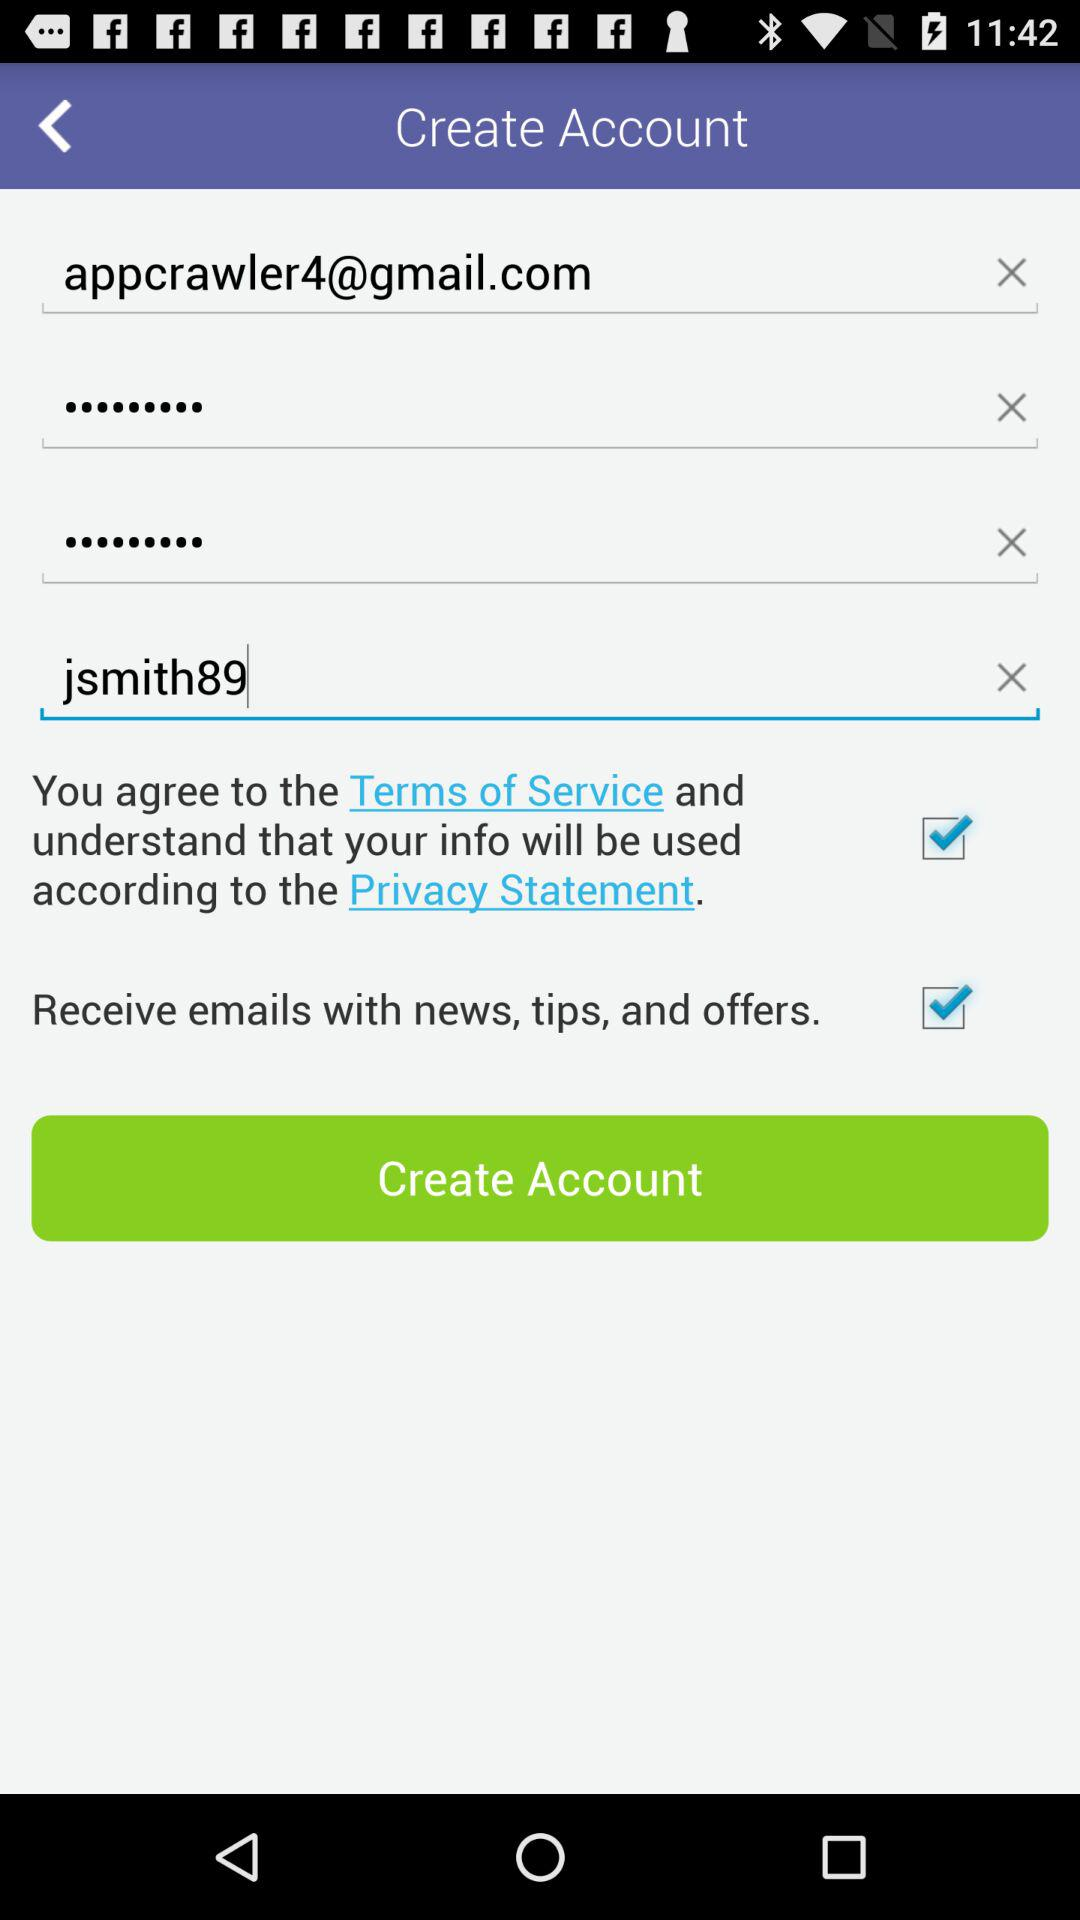What is the email address? The email address is appcrawler4@gmail.com. 